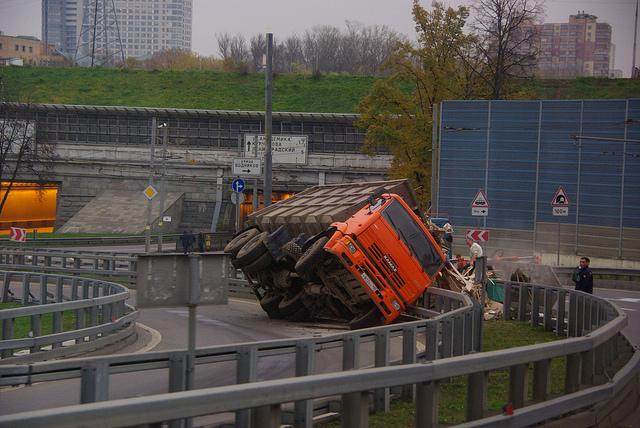Which speed during the turn caused this to happen? high speed 